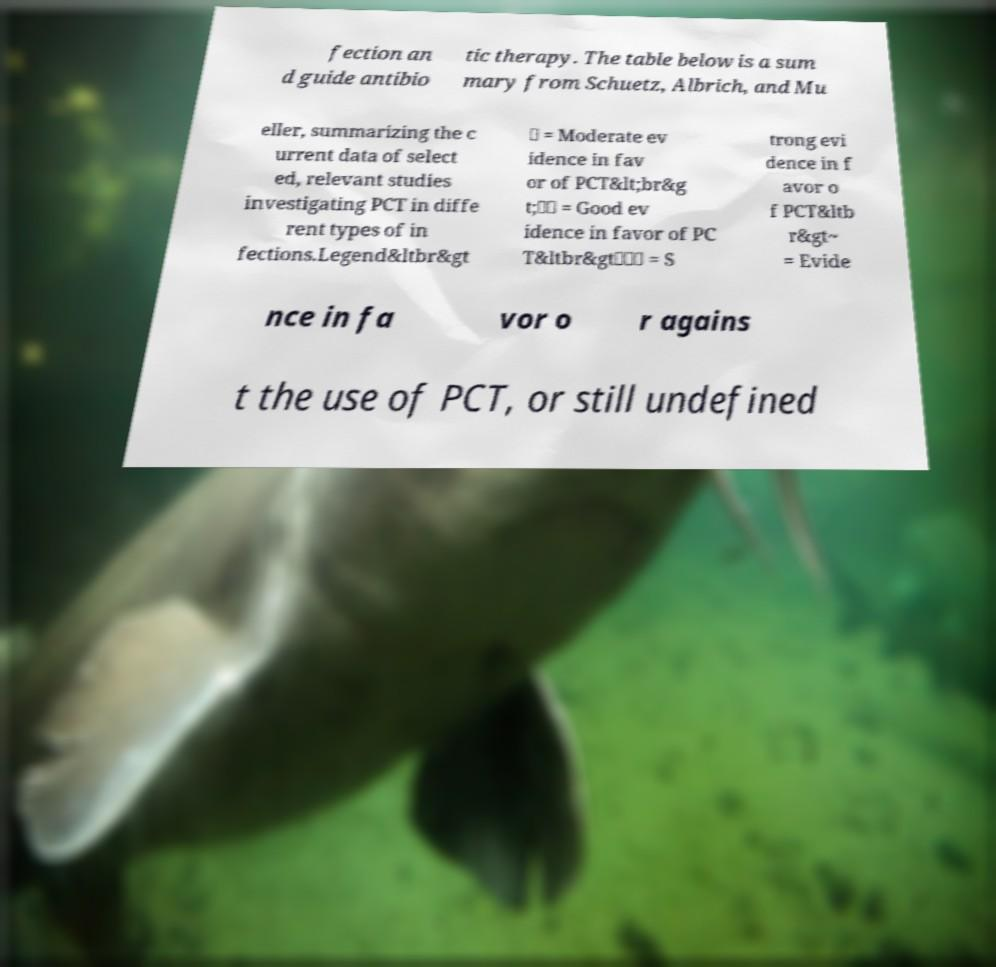I need the written content from this picture converted into text. Can you do that? fection an d guide antibio tic therapy. The table below is a sum mary from Schuetz, Albrich, and Mu eller, summarizing the c urrent data of select ed, relevant studies investigating PCT in diffe rent types of in fections.Legend&ltbr&gt ✓ = Moderate ev idence in fav or of PCT&lt;br&g t;✓✓ = Good ev idence in favor of PC T&ltbr&gt✓✓✓ = S trong evi dence in f avor o f PCT&ltb r&gt~ = Evide nce in fa vor o r agains t the use of PCT, or still undefined 